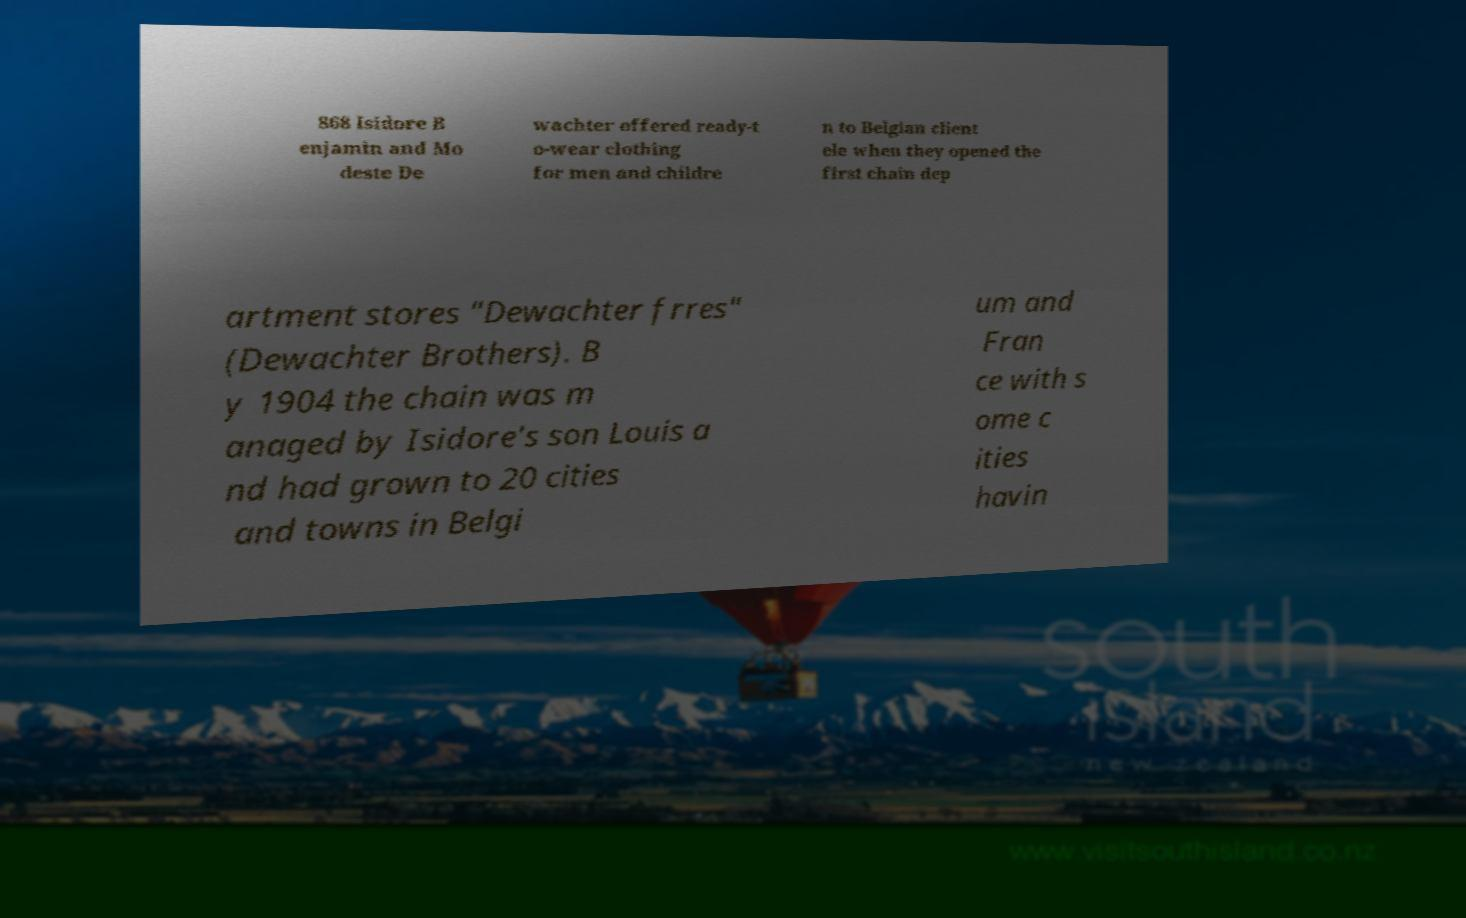Could you extract and type out the text from this image? 868 Isidore B enjamin and Mo deste De wachter offered ready-t o-wear clothing for men and childre n to Belgian client ele when they opened the first chain dep artment stores "Dewachter frres" (Dewachter Brothers). B y 1904 the chain was m anaged by Isidore's son Louis a nd had grown to 20 cities and towns in Belgi um and Fran ce with s ome c ities havin 